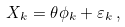<formula> <loc_0><loc_0><loc_500><loc_500>X _ { k } = \theta \phi _ { k } + \varepsilon _ { k } \, ,</formula> 